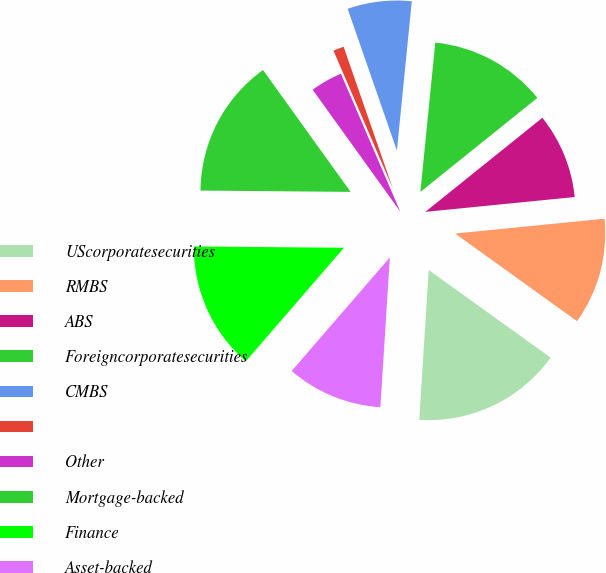Convert chart to OTSL. <chart><loc_0><loc_0><loc_500><loc_500><pie_chart><fcel>UScorporatesecurities<fcel>RMBS<fcel>ABS<fcel>Foreigncorporatesecurities<fcel>CMBS<fcel>Unnamed: 5<fcel>Other<fcel>Mortgage-backed<fcel>Finance<fcel>Asset-backed<nl><fcel>16.09%<fcel>11.49%<fcel>9.2%<fcel>12.64%<fcel>6.9%<fcel>1.15%<fcel>3.45%<fcel>14.94%<fcel>13.79%<fcel>10.34%<nl></chart> 